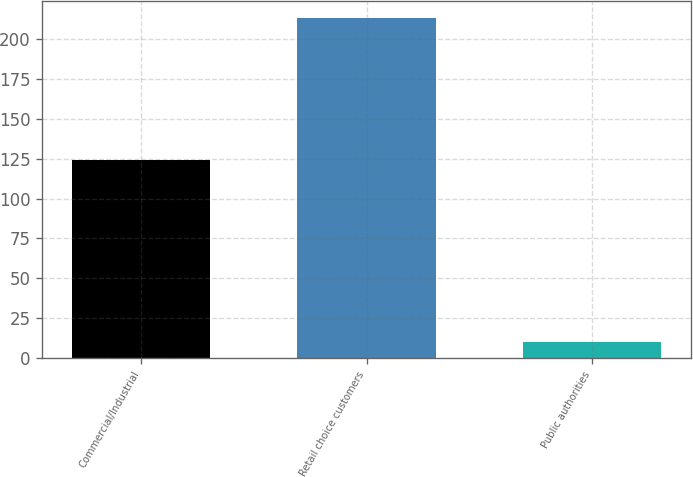Convert chart. <chart><loc_0><loc_0><loc_500><loc_500><bar_chart><fcel>Commercial/Industrial<fcel>Retail choice customers<fcel>Public authorities<nl><fcel>124<fcel>213<fcel>10<nl></chart> 